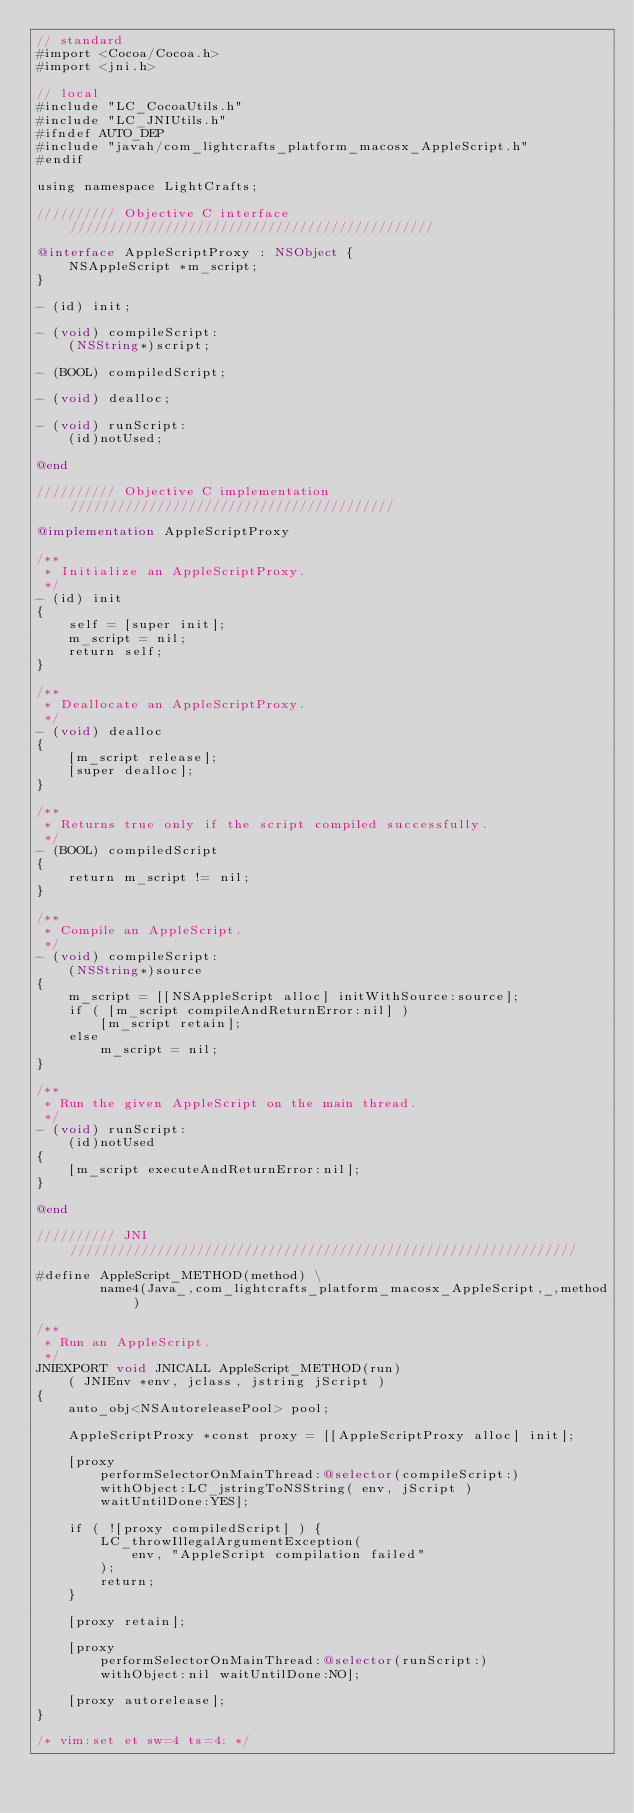<code> <loc_0><loc_0><loc_500><loc_500><_ObjectiveC_>// standard
#import <Cocoa/Cocoa.h>
#import <jni.h>

// local
#include "LC_CocoaUtils.h"
#include "LC_JNIUtils.h"
#ifndef AUTO_DEP
#include "javah/com_lightcrafts_platform_macosx_AppleScript.h"
#endif

using namespace LightCrafts;

////////// Objective C interface //////////////////////////////////////////////

@interface AppleScriptProxy : NSObject {
    NSAppleScript *m_script;
}

- (id) init;

- (void) compileScript:
    (NSString*)script;

- (BOOL) compiledScript;

- (void) dealloc;

- (void) runScript:
    (id)notUsed;

@end

////////// Objective C implementation /////////////////////////////////////////

@implementation AppleScriptProxy

/**
 * Initialize an AppleScriptProxy.
 */
- (id) init
{
    self = [super init];
    m_script = nil;
    return self;
}

/**
 * Deallocate an AppleScriptProxy.
 */
- (void) dealloc
{
    [m_script release];
    [super dealloc];
}

/**
 * Returns true only if the script compiled successfully.
 */
- (BOOL) compiledScript
{
    return m_script != nil;
}

/**
 * Compile an AppleScript.
 */
- (void) compileScript:
    (NSString*)source
{
    m_script = [[NSAppleScript alloc] initWithSource:source];
    if ( [m_script compileAndReturnError:nil] )
        [m_script retain];
    else
        m_script = nil;
}

/**
 * Run the given AppleScript on the main thread.
 */
- (void) runScript:
    (id)notUsed
{
    [m_script executeAndReturnError:nil];
}

@end

////////// JNI ////////////////////////////////////////////////////////////////

#define AppleScript_METHOD(method) \
        name4(Java_,com_lightcrafts_platform_macosx_AppleScript,_,method)

/**
 * Run an AppleScript.
 */
JNIEXPORT void JNICALL AppleScript_METHOD(run)
    ( JNIEnv *env, jclass, jstring jScript )
{
    auto_obj<NSAutoreleasePool> pool;

    AppleScriptProxy *const proxy = [[AppleScriptProxy alloc] init];

    [proxy
        performSelectorOnMainThread:@selector(compileScript:)
        withObject:LC_jstringToNSString( env, jScript )
        waitUntilDone:YES];

    if ( ![proxy compiledScript] ) {
        LC_throwIllegalArgumentException(
            env, "AppleScript compilation failed"
        );
        return;
    }

    [proxy retain];

    [proxy
        performSelectorOnMainThread:@selector(runScript:)
        withObject:nil waitUntilDone:NO];

    [proxy autorelease];
}

/* vim:set et sw=4 ts=4: */
</code> 